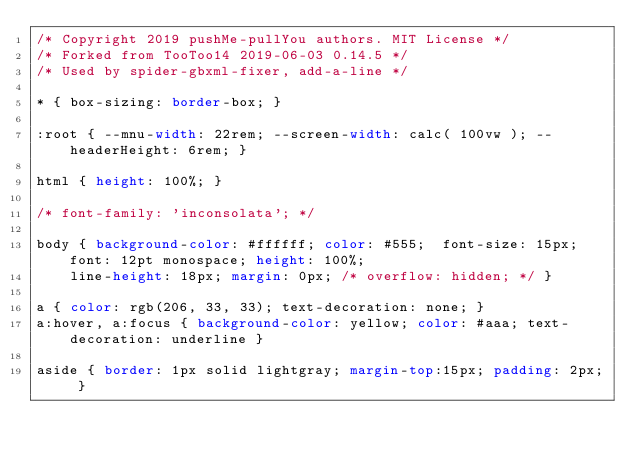Convert code to text. <code><loc_0><loc_0><loc_500><loc_500><_CSS_>/* Copyright 2019 pushMe-pullYou authors. MIT License */
/* Forked from TooToo14 2019-06-03 0.14.5 */
/* Used by spider-gbxml-fixer, add-a-line */

* { box-sizing: border-box; }

:root { --mnu-width: 22rem; --screen-width: calc( 100vw ); --headerHeight: 6rem; }

html { height: 100%; }

/* font-family: 'inconsolata'; */

body { background-color: #ffffff; color: #555;  font-size: 15px; font: 12pt monospace; height: 100%;
	line-height: 18px; margin: 0px; /* overflow: hidden; */ }

a { color: rgb(206, 33, 33); text-decoration: none; }
a:hover, a:focus { background-color: yellow; color: #aaa; text-decoration: underline }

aside { border: 1px solid lightgray; margin-top:15px; padding: 2px; }
</code> 